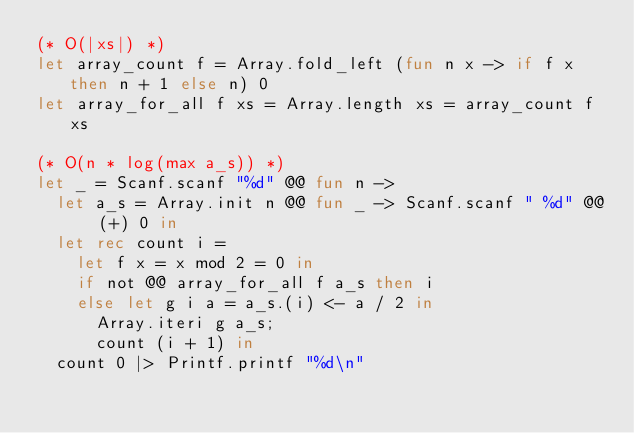<code> <loc_0><loc_0><loc_500><loc_500><_OCaml_>(* O(|xs|) *)
let array_count f = Array.fold_left (fun n x -> if f x then n + 1 else n) 0
let array_for_all f xs = Array.length xs = array_count f xs

(* O(n * log(max a_s)) *)
let _ = Scanf.scanf "%d" @@ fun n ->
  let a_s = Array.init n @@ fun _ -> Scanf.scanf " %d" @@ (+) 0 in
  let rec count i =
    let f x = x mod 2 = 0 in
    if not @@ array_for_all f a_s then i
    else let g i a = a_s.(i) <- a / 2 in
      Array.iteri g a_s;
      count (i + 1) in
  count 0 |> Printf.printf "%d\n"</code> 